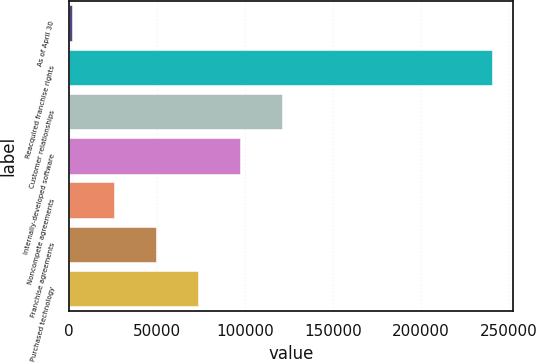<chart> <loc_0><loc_0><loc_500><loc_500><bar_chart><fcel>As of April 30<fcel>Reacquired franchise rights<fcel>Customer relationships<fcel>Internally-developed software<fcel>Noncompete agreements<fcel>Franchise agreements<fcel>Purchased technology<nl><fcel>2017<fcel>240273<fcel>121145<fcel>97319.4<fcel>25842.6<fcel>49668.2<fcel>73493.8<nl></chart> 